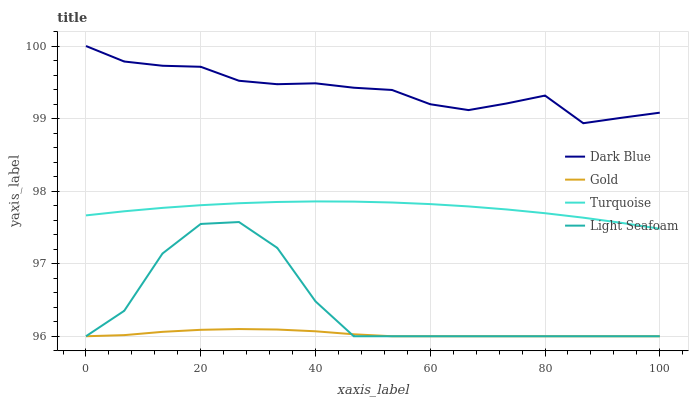Does Gold have the minimum area under the curve?
Answer yes or no. Yes. Does Dark Blue have the maximum area under the curve?
Answer yes or no. Yes. Does Turquoise have the minimum area under the curve?
Answer yes or no. No. Does Turquoise have the maximum area under the curve?
Answer yes or no. No. Is Turquoise the smoothest?
Answer yes or no. Yes. Is Light Seafoam the roughest?
Answer yes or no. Yes. Is Light Seafoam the smoothest?
Answer yes or no. No. Is Turquoise the roughest?
Answer yes or no. No. Does Turquoise have the lowest value?
Answer yes or no. No. Does Turquoise have the highest value?
Answer yes or no. No. Is Gold less than Dark Blue?
Answer yes or no. Yes. Is Dark Blue greater than Turquoise?
Answer yes or no. Yes. Does Gold intersect Dark Blue?
Answer yes or no. No. 